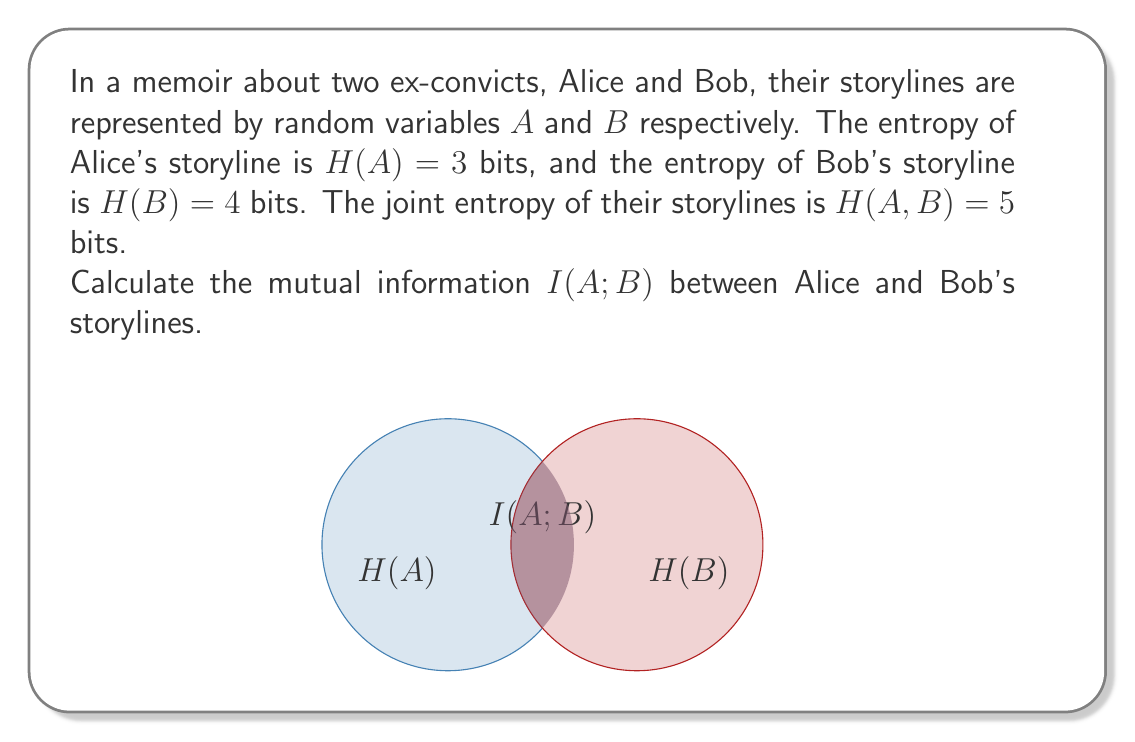Help me with this question. To solve this problem, we'll use the relationship between entropy, joint entropy, and mutual information. The steps are as follows:

1) The mutual information I(A;B) is related to the individual entropies H(A) and H(B) and the joint entropy H(A,B) by the following equation:

   $$I(A;B) = H(A) + H(B) - H(A,B)$$

2) We are given:
   H(A) = 3 bits
   H(B) = 4 bits
   H(A,B) = 5 bits

3) Let's substitute these values into the equation:

   $$I(A;B) = 3 + 4 - 5$$

4) Simplify:

   $$I(A;B) = 2$$

Therefore, the mutual information between Alice and Bob's storylines is 2 bits.

This means that 2 bits of information are shared between their storylines, indicating a significant overlap or connection between their narratives in the memoir.
Answer: 2 bits 